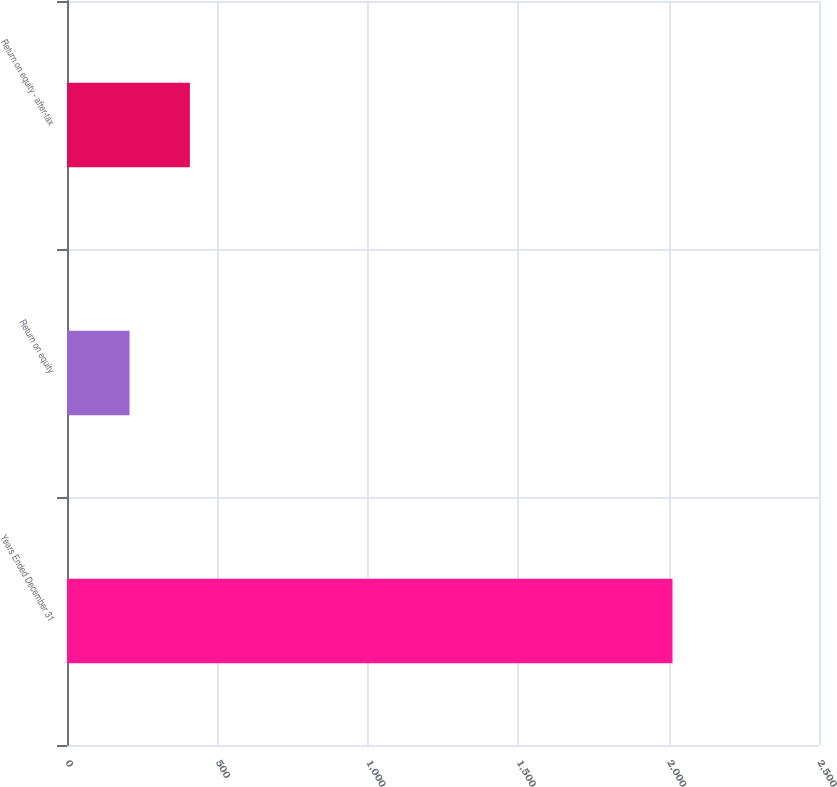<chart> <loc_0><loc_0><loc_500><loc_500><bar_chart><fcel>Years Ended December 31<fcel>Return on equity<fcel>Return on equity - after-tax<nl><fcel>2013<fcel>207.96<fcel>408.52<nl></chart> 